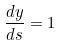<formula> <loc_0><loc_0><loc_500><loc_500>\frac { d y } { d s } = 1</formula> 